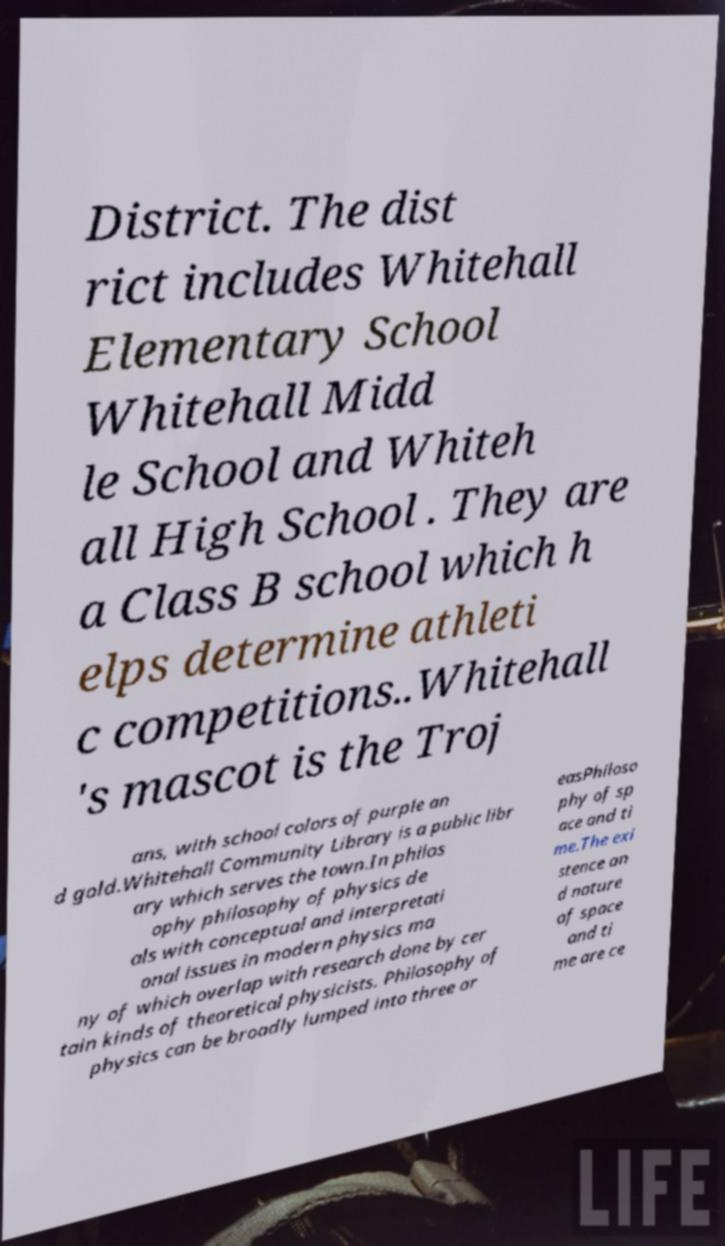What messages or text are displayed in this image? I need them in a readable, typed format. District. The dist rict includes Whitehall Elementary School Whitehall Midd le School and Whiteh all High School . They are a Class B school which h elps determine athleti c competitions..Whitehall 's mascot is the Troj ans, with school colors of purple an d gold.Whitehall Community Library is a public libr ary which serves the town.In philos ophy philosophy of physics de als with conceptual and interpretati onal issues in modern physics ma ny of which overlap with research done by cer tain kinds of theoretical physicists. Philosophy of physics can be broadly lumped into three ar easPhiloso phy of sp ace and ti me.The exi stence an d nature of space and ti me are ce 